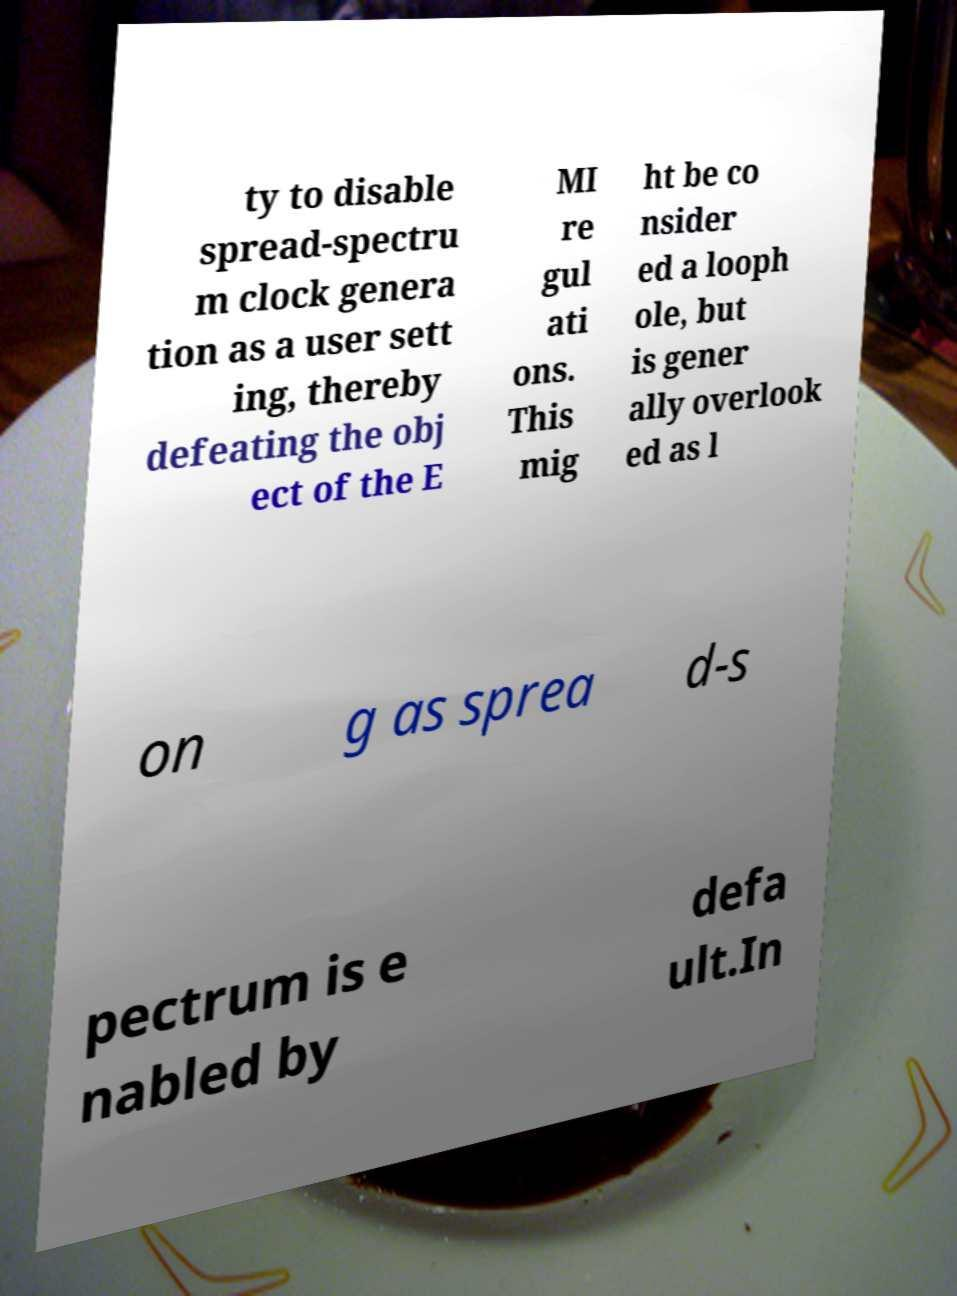For documentation purposes, I need the text within this image transcribed. Could you provide that? ty to disable spread-spectru m clock genera tion as a user sett ing, thereby defeating the obj ect of the E MI re gul ati ons. This mig ht be co nsider ed a looph ole, but is gener ally overlook ed as l on g as sprea d-s pectrum is e nabled by defa ult.In 